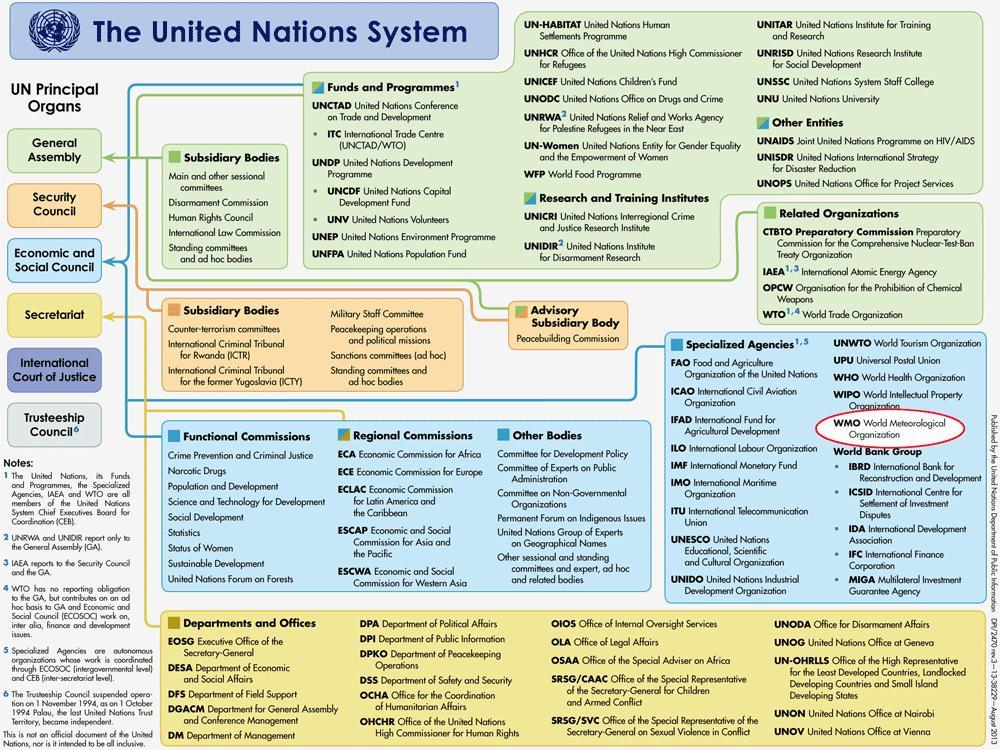International Law Commission comes under which principal organ of United Nations?
Answer the question with a short phrase. General Assembly How many principal organs are there for United Nations? 6 What is the definition for FAO? Food and Agriculture Organization of the United Nations Which is the 5th principal organ of United Nations? International Court of Justice How many Subsidiary bodies are there for UN General Assembly? 5 How many sections are under General Assembly of United Nations? 4 Department of Political Affairs comes under which principal organ of United Nations? Secretariat How many sections are under Security Council of united Nations? 2 How many Subsidiary bodies are there for UN Security Council? 7 WMO World Meteorological Organization falls under which principal organ of United Nations? Economic and Social Council 